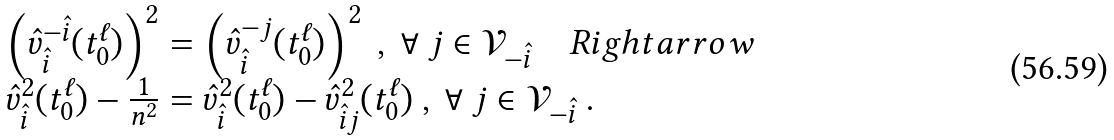Convert formula to latex. <formula><loc_0><loc_0><loc_500><loc_500>\begin{array} { l l l l } & \left ( \hat { v } ^ { - \hat { i } } _ { \hat { i } } ( t ^ { \ell } _ { 0 } ) \right ) ^ { 2 } = \left ( \hat { v } ^ { - j } _ { \hat { i } } ( t ^ { \ell } _ { 0 } ) \right ) ^ { 2 } \ , \ \forall \ j \in \mathcal { V } _ { - \hat { i } } \quad R i g h t a r r o w \\ & \hat { v } _ { \hat { i } } ^ { 2 } ( t ^ { \ell } _ { 0 } ) - \frac { 1 } { n ^ { 2 } } = \hat { v } _ { \hat { i } } ^ { 2 } ( t ^ { \ell } _ { 0 } ) - \hat { v } _ { \hat { i } j } ^ { 2 } ( t ^ { \ell } _ { 0 } ) \ , \ \forall \ j \in \mathcal { V } _ { - \hat { i } } \ . \end{array}</formula> 